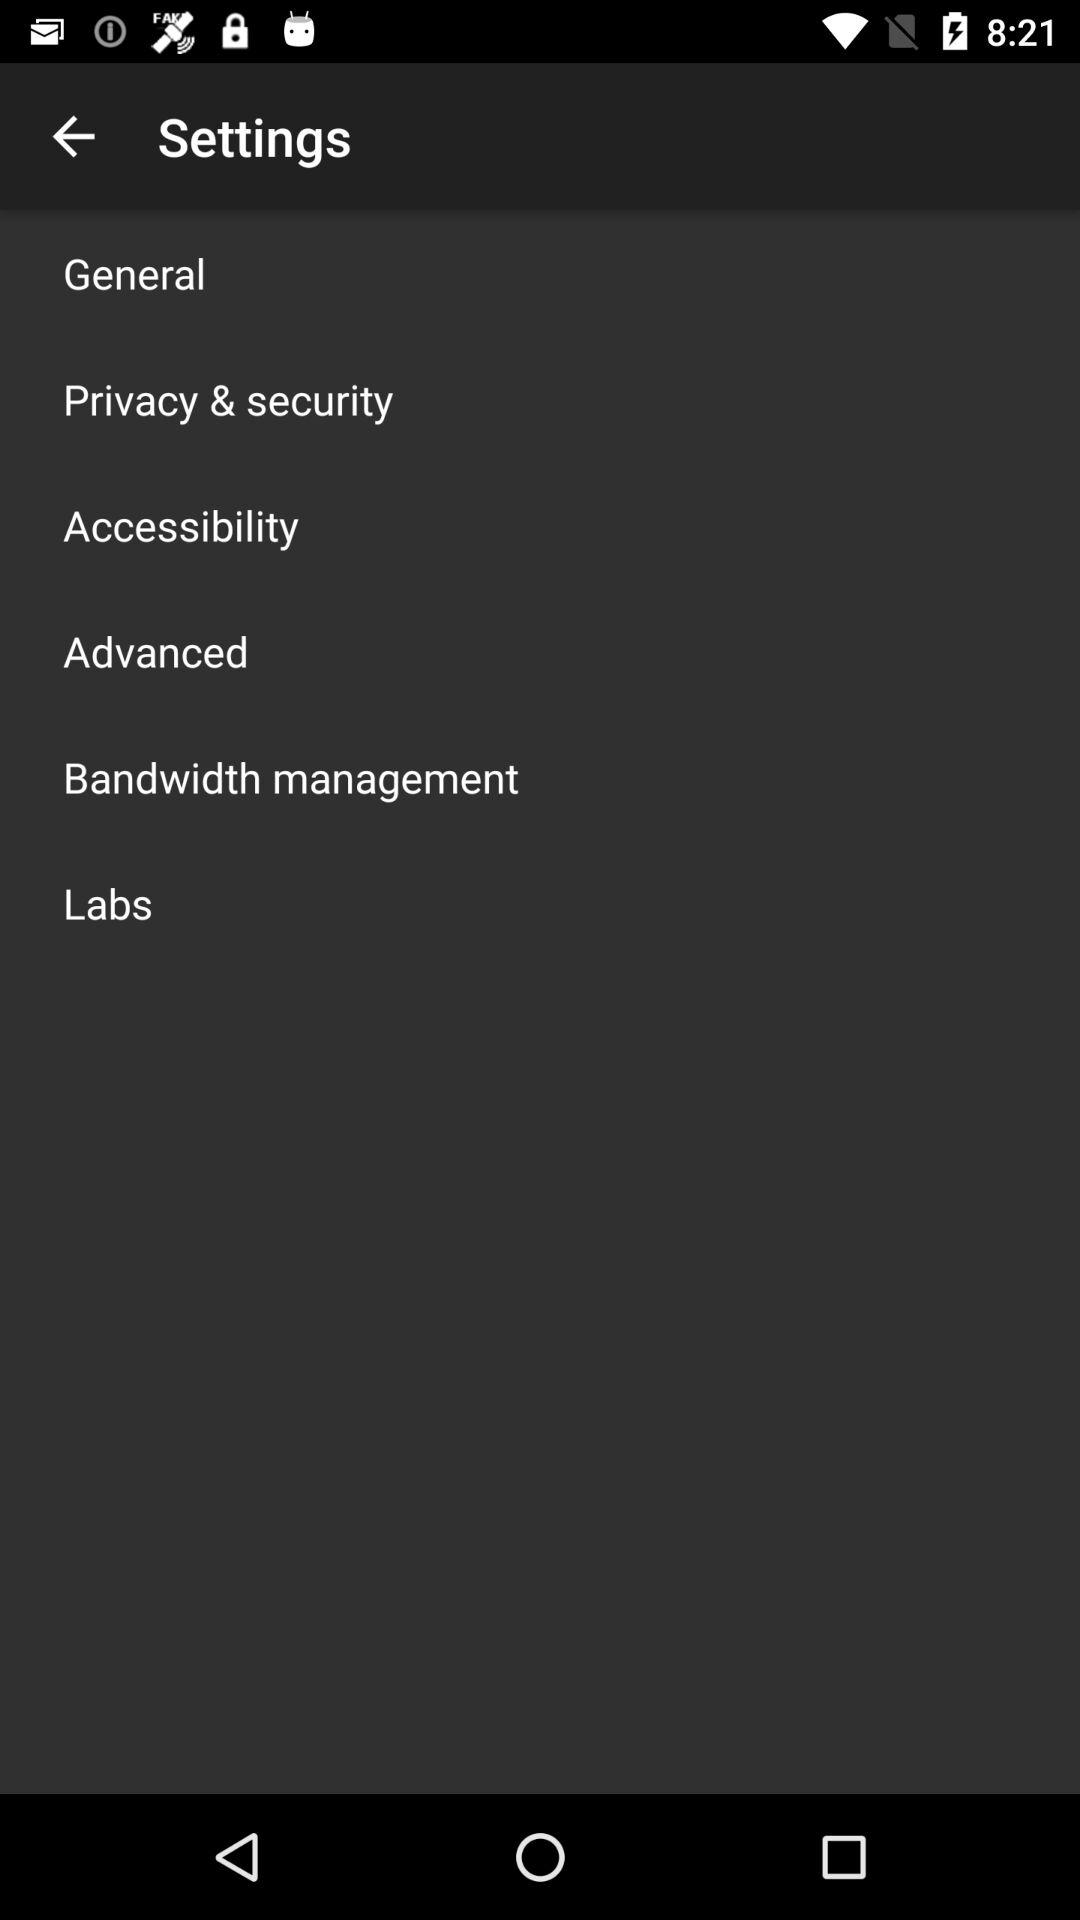How many items are in the settings menu?
Answer the question using a single word or phrase. 6 